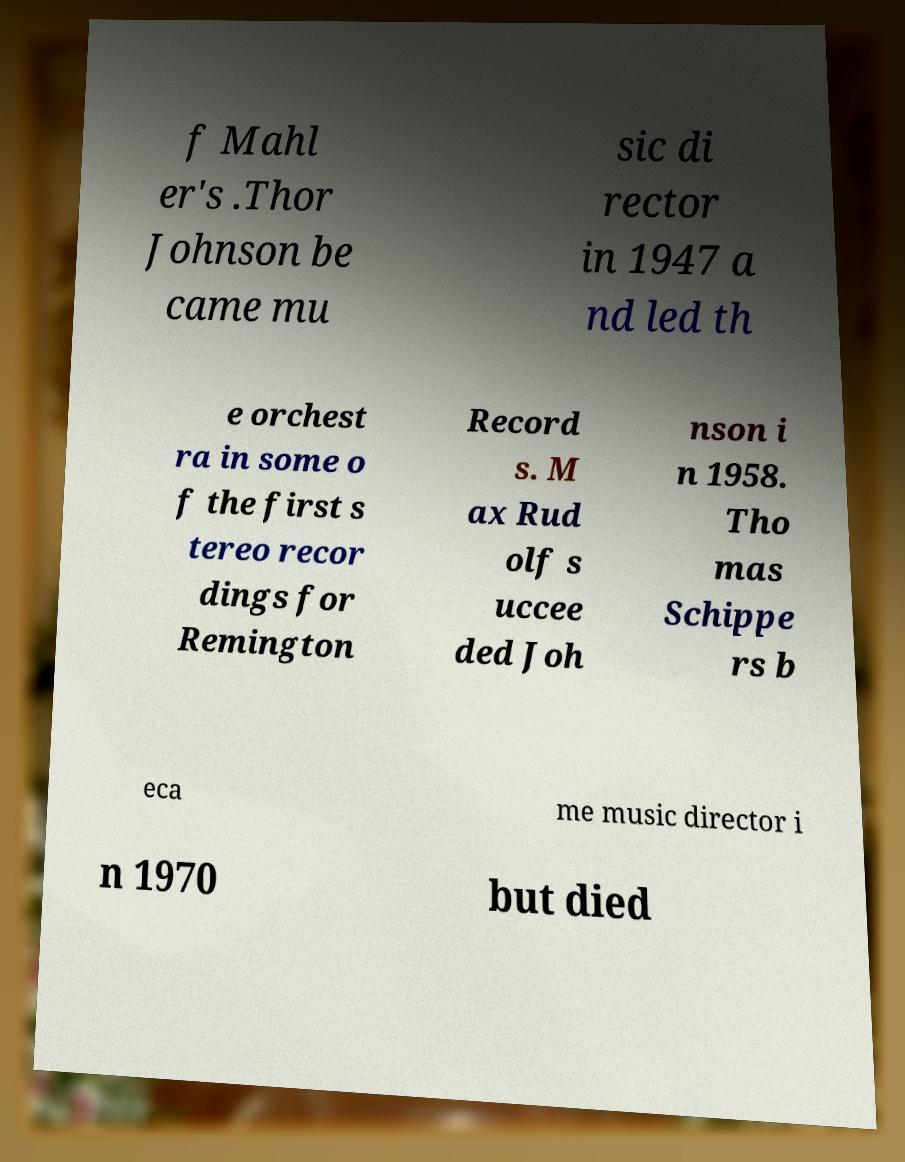What messages or text are displayed in this image? I need them in a readable, typed format. f Mahl er's .Thor Johnson be came mu sic di rector in 1947 a nd led th e orchest ra in some o f the first s tereo recor dings for Remington Record s. M ax Rud olf s uccee ded Joh nson i n 1958. Tho mas Schippe rs b eca me music director i n 1970 but died 